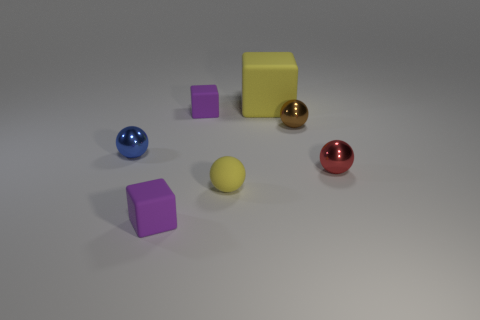Subtract all yellow spheres. How many spheres are left? 3 Subtract all blue cylinders. How many purple blocks are left? 2 Subtract all brown balls. How many balls are left? 3 Add 2 big yellow things. How many objects exist? 9 Subtract all blocks. How many objects are left? 4 Subtract 2 blocks. How many blocks are left? 1 Add 2 yellow rubber things. How many yellow rubber things exist? 4 Subtract 1 blue spheres. How many objects are left? 6 Subtract all yellow balls. Subtract all gray cubes. How many balls are left? 3 Subtract all tiny blue cylinders. Subtract all small metallic things. How many objects are left? 4 